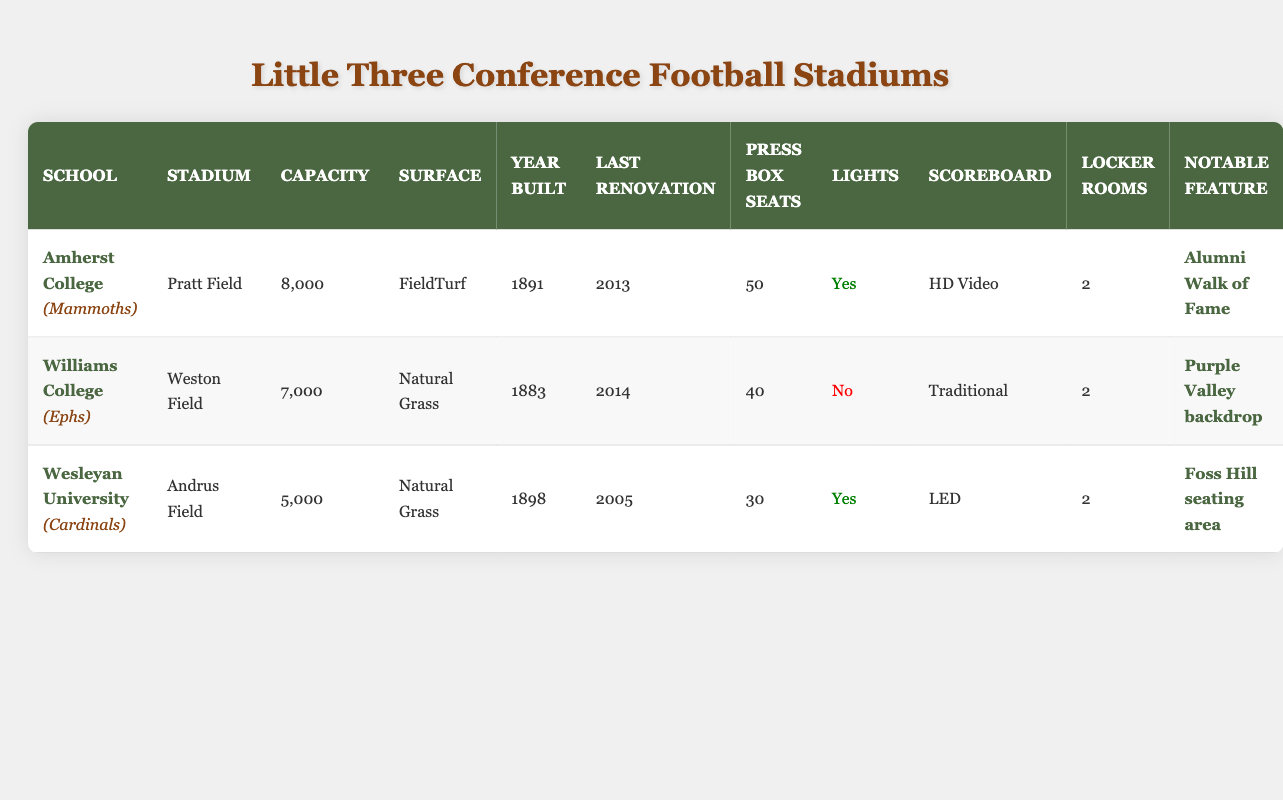What is the seating capacity of Pratt Field? Pratt Field is the stadium for Amherst College, and its capacity is explicitly listed in the table.
Answer: 8000 Which school has the highest stadium capacity? By comparing the capacities listed for each school, Amherst College has the highest capacity at 8000, in contrast to Williams College with 7000 and Wesleyan University with 5000.
Answer: Amherst College Do Williams College's Weston Field have lights? The table specifies whether each stadium has lights. For Weston Field at Williams College, it is indicated that there are no lights present (marked as false).
Answer: No What is the average seating capacity of all three schools? To find the average seating capacity, sum the capacities (8000 + 7000 + 5000 = 20000) and divide by the number of schools (3). Thus, the average is 20000/3, which equals approximately 6667.
Answer: 6667 Which school features a notable alumni walk of fame? The notable feature listed for Amherst College is the "Alumni Walk of Fame," which can be quickly identified in the table.
Answer: Amherst College How many press box seats are there in total across all schools? The total number of press box seats is obtained by adding the press box seats from all schools: (50 + 40 + 30 = 120). Therefore, the total equals 120 seats.
Answer: 120 What is the difference in capacity between Weston Field and Andrus Field? To find the difference in capacity, subtract the capacity of Andrus Field (5000) from Weston Field (7000). Thus, the difference is 7000 - 5000 = 2000.
Answer: 2000 Which school has the newest stadium renovation and what year was it? The last renovation for each stadium is noted: Amherst College was last renovated in 2013, Williams College in 2014, and Wesleyan University in 2005. Williams College’s Weston Field has the latest renovation in 2014.
Answer: Williams College, 2014 Is the surface of Andrus Field grass or synthetic? The table shows that Andrus Field at Wesleyan University has a surface of "Natural Grass."
Answer: Natural Grass 